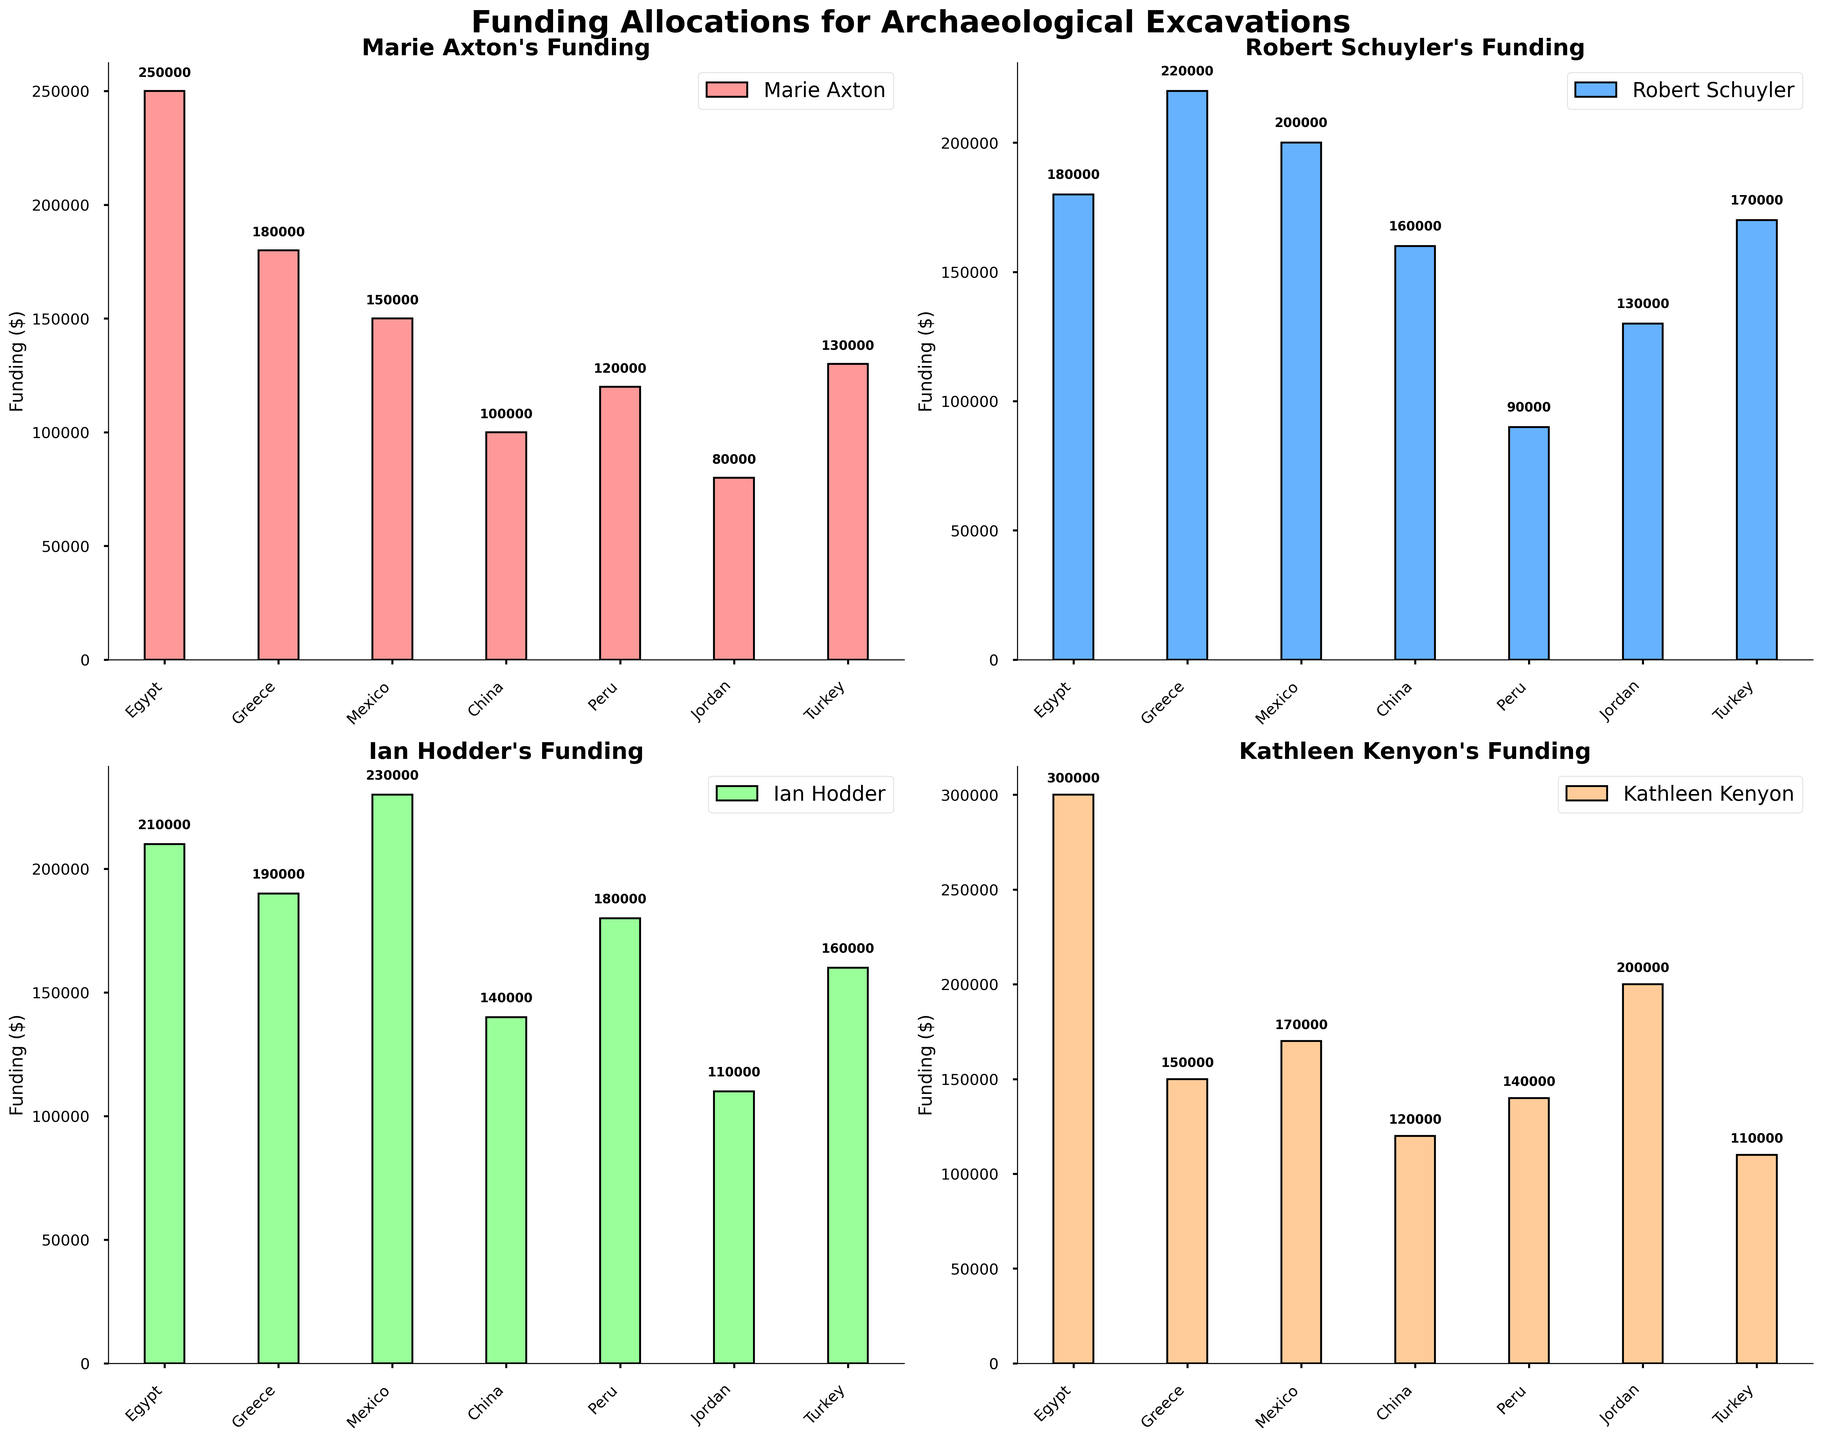What are the regions listed in the subplots? The regions are displayed on the x-axis labels of each subplot. They are Egypt, Greece, Mexico, China, Peru, Jordan, and Turkey, which are consistent across all subplots.
Answer: Egypt, Greece, Mexico, China, Peru, Jordan, Turkey What is the funding amount for Marie Axton's projects in Egypt? The funding for Marie Axton in Egypt is indicated by the height of the corresponding bar in the first subplot, labeled with the amount just above the bar.
Answer: 250000 Which researcher received the highest funding in Peru? By comparing the heights of the bars in the subplot for Peru, we can see which bar is the tallest. Kathleen Kenyon received the highest funding in Peru, as indicated by the tallest bar in her subplot, representing 140000.
Answer: Kathleen Kenyon How does Ian Hodder's funding in China compare to Robert Schuyler's funding in the same region? Comparing the bars for China in the subplots for Ian Hodder and Robert Schuyler, Ian Hodder received 140000 and Robert Schuyler received 160000. Hence, Robert Schuyler received more funding in China than Ian Hodder.
Answer: Robert Schuyler received more What is the total funding Marie Axton received for all projects combined? Sum the values of Marie Axton's funding across all regions: 250000 (Egypt) + 180000 (Greece) + 150000 (Mexico) + 100000 (China) + 120000 (Peru) + 80000 (Jordan) + 130000 (Turkey) = 1010000.
Answer: 1010000 Who received the lowest funding in any single region, and what is the amount? Identify the smallest bar across all subplots. The lowest funding is for Marie Axton in Jordan, where she received 80000.
Answer: Marie Axton, 80000 In which regions did every researcher receive funding greater than 100000? Check each region to see if all bars in all subplots are above 100000. The regions where every researcher received more than 100000 are Egypt, Mexico, and Turkey.
Answer: Egypt, Mexico, Turkey Compare the average funding received by Marie Axton and Kathleen Kenyon. Who has the higher average funding? Calculate the total and average funding for both researchers. Marie Axton's total funding is 1010000, and the average is 144285.71 (1010000 ÷ 7). Kathleen Kenyon's total funding is 1190000, and the average is 170000 (1190000 ÷ 7). Kathleen Kenyon has a higher average funding.
Answer: Kathleen Kenyon What is the difference in funding between Robert Schuyler and Ian Hodder for their projects in Turkey? Compare the heights of the bars for Turkey in Robert Schuyler's and Ian Hodder's subplots. Robert Schuyler received 170000, and Ian Hodder received 160000. The difference is 170000 - 160000 = 10000.
Answer: 10000 What range of funding amounts did Robert Schuyler's projects receive? Identify the minimum and maximum funding amounts for Robert Schuyler from his subplot. The range is determined by the difference between the maximum (220000 for Greece) and the minimum (90000 for Peru). The funding range is 220000 - 90000 = 130000.
Answer: 130000 